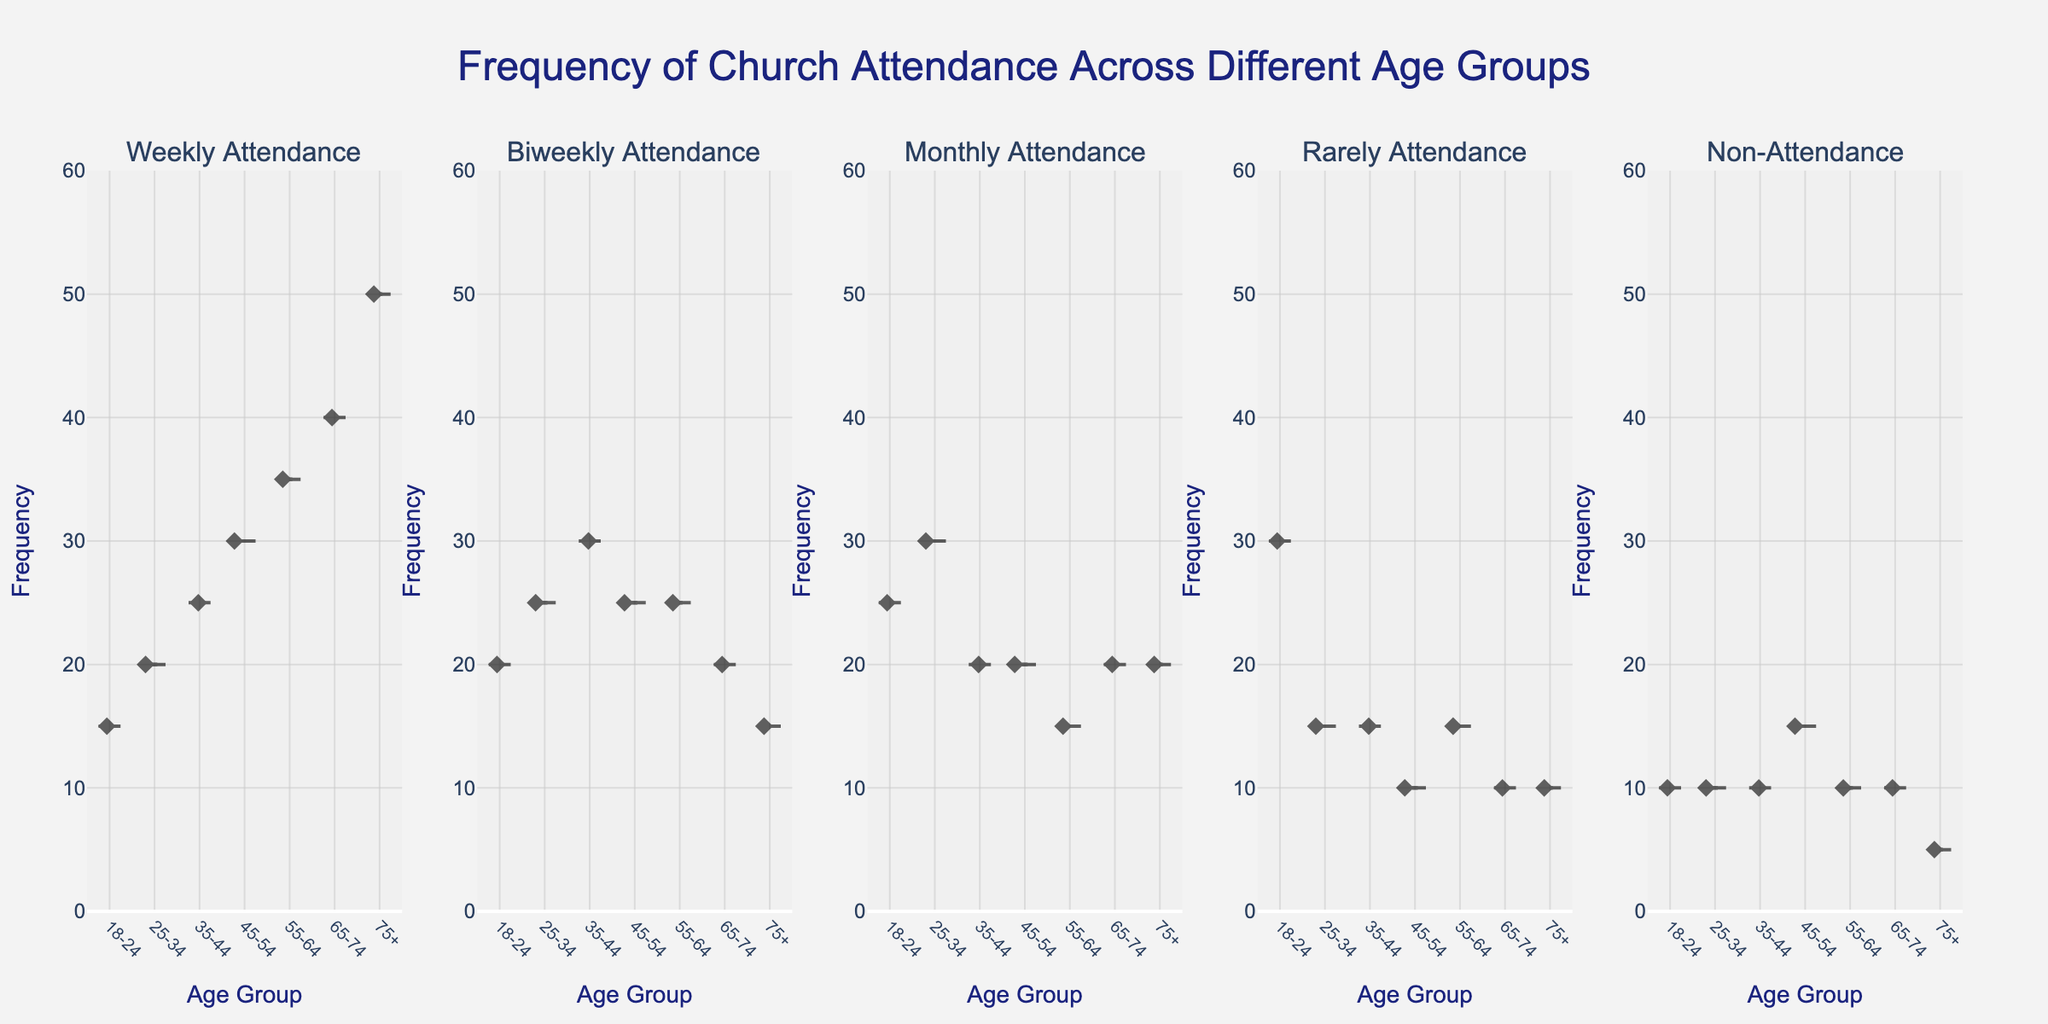What's the title of the figure? The title is typically displayed at the top of the figure. Reading it directly, it states "Frequency of Church Attendance Across Different Age Groups".
Answer: Frequency of Church Attendance Across Different Age Groups What's the range of the y-axis? The range of the y-axis can be identified by looking at the lowest and highest values indicated along the y-axis. The range is from 0 to 60.
Answer: 0 to 60 Which age group has the highest weekly attendance? By comparing the weekly attendance values across the age groups in the violin plot for "Weekly Attendance", the age group 75+ has the highest value, which is 50.
Answer: 75+ Is the meanline visible in the plots? The meanline is a visual component that appears as a horizontal line within each violin plot, indicating its visible presence.
Answer: Yes Which attendance category shows the most variation across age groups? Variation can be gauged by the spread within each violin plot. The "Biweekly Attendance" category exhibits a relatively large spread across the different age groups compared to others.
Answer: Biweekly Attendance Do any age groups show low attendance in all categories? By inspecting the violin plots for all categories, the 75+ age group consistently shows relatively low frequencies in Biweekly, Monthly, Rarely, and Non-Attendance categories compared to other groups.
Answer: 75+ Between which two age groups does the frequency of Monthly Attendance decrease the most? Comparing the values for Monthly Attendance across adjacent age groups, the frequency decreases the most from 25-34 (30) to 35-44 (20), which is a decrease of 10.
Answer: 25-34 to 35-44 How does the Non-Attendance frequency compare between the youngest and oldest age groups? Comparing the Non-Attendance frequencies of the 18-24 age group (10) and the 75+ age group (5), the youngest age group has double the frequency of the oldest age group.
Answer: Youngest group has double Which age group has the highest variability in Monthly Attendance frequency? Variability can be inferred from the spread within the corresponding violin plot. The 18-24 age group shows higher spread visually than others in Monthly Attendance.
Answer: 18-24 What is the attendance trend as age increases? Observing each plot from left to right for all ages, there is an increasing trend in Weekly Attendance and a decreasing trend in Non-Attendance as age increases from youngest to oldest groups.
Answer: Weekly Attendance increases, Non-Attendance decreases 